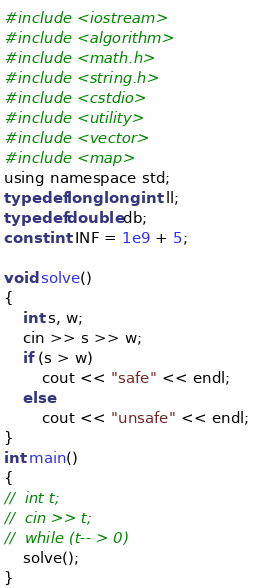Convert code to text. <code><loc_0><loc_0><loc_500><loc_500><_C_>#include <iostream>
#include <algorithm>
#include <math.h>
#include <string.h>
#include <cstdio>
#include <utility>
#include <vector>
#include <map>
using namespace std;
typedef long long int ll;
typedef double db;
const int INF = 1e9 + 5;

void solve()
{
	int s, w;
	cin >> s >> w;
	if (s > w)
		cout << "safe" << endl;
	else
		cout << "unsafe" << endl;
}
int main()
{
//	int t;
//	cin >> t;
//	while (t-- > 0)
	solve();
}
</code> 